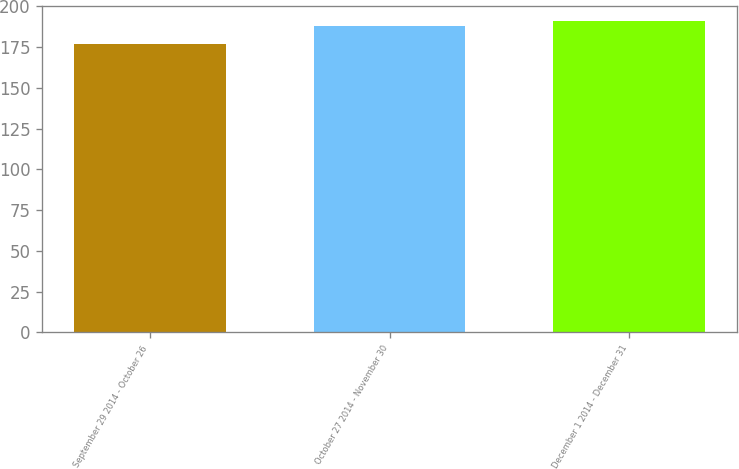Convert chart to OTSL. <chart><loc_0><loc_0><loc_500><loc_500><bar_chart><fcel>September 29 2014 - October 26<fcel>October 27 2014 - November 30<fcel>December 1 2014 - December 31<nl><fcel>176.96<fcel>187.74<fcel>190.81<nl></chart> 